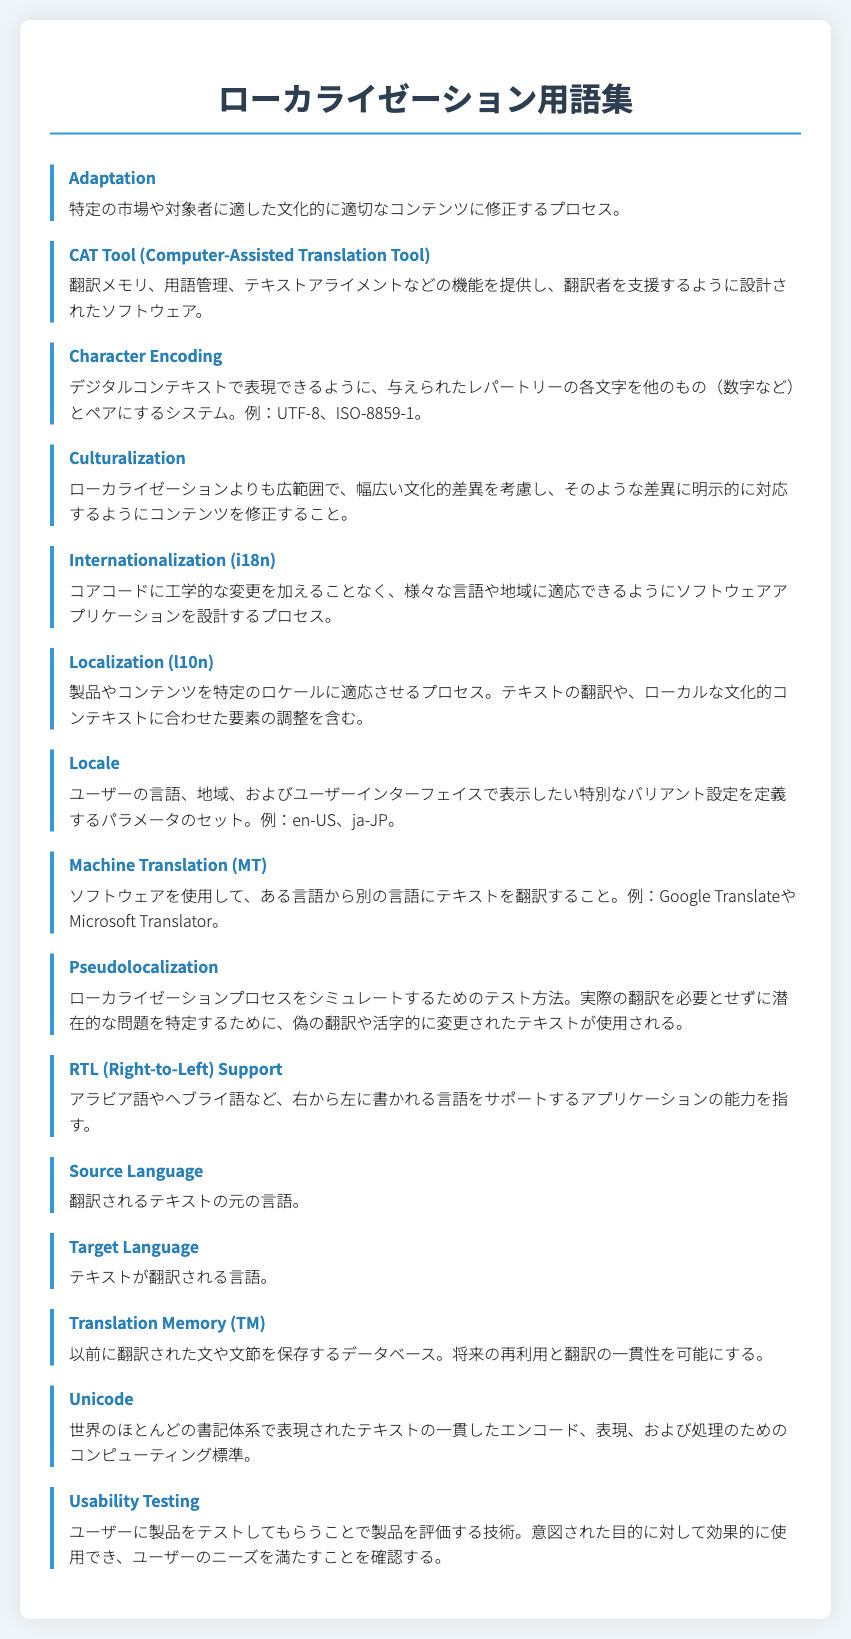What is the term for modifying content to be culturally appropriate for a specific market? The document defines "Adaptation" as the process of modifying content to be culturally appropriate for a specific market or audience.
Answer: Adaptation What does the acronym i18n stand for? In the context of the document, "i18n" is an abbreviation for "Internationalization," referring to designing software applications to adapt to various languages and regions without engineering changes.
Answer: Internationalization What is a CAT Tool? A CAT Tool is defined in the document as software designed to assist translators with features like translation memory and terminology management.
Answer: Computer-Assisted Translation Tool Which encoding system is mentioned for digital contexts? The document lists "UTF-8" as an example of a character encoding system for representing characters in digital contexts.
Answer: UTF-8 What type of testing involves evaluating a product by users? "Usability Testing" is the process described in the document where users test a product to evaluate its effectiveness for its intended purpose.
Answer: Usability Testing Which languages are supported by RTL? The document specifically mentions Arabic and Hebrew as examples of languages that are read from right to left (RTL).
Answer: Arabic, Hebrew How does the document define Translation Memory? Translation Memory is defined as a database that stores previously translated sentences or phrases for future reuse and consistency.
Answer: Translation Memory What does "Culturalization" focus on compared to localization? The document states that "Culturalization" is broader than localization and explicitly addresses a wide range of cultural differences.
Answer: Cultural differences 